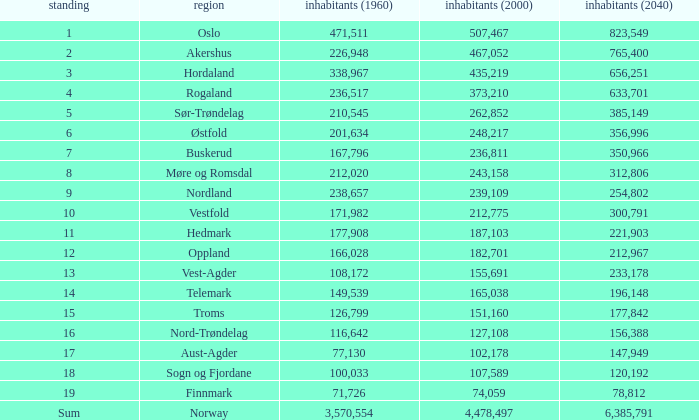What was Oslo's population in 1960, with a population of 507,467 in 2000? None. 